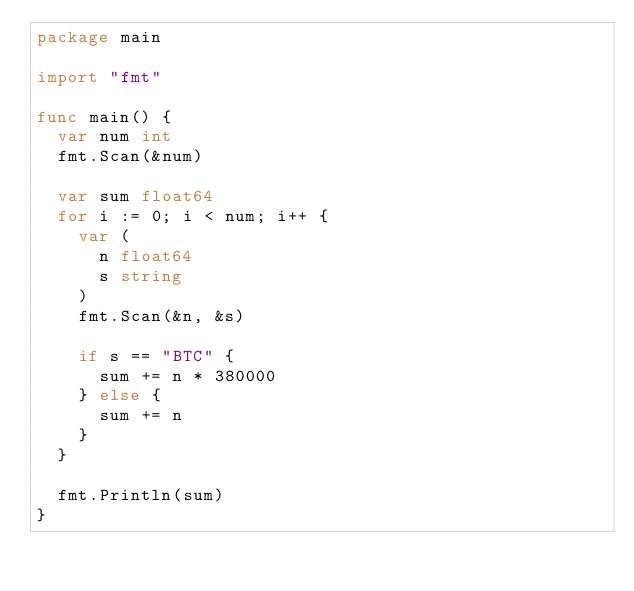<code> <loc_0><loc_0><loc_500><loc_500><_Go_>package main

import "fmt"

func main() {
	var num int
	fmt.Scan(&num)

	var sum float64
	for i := 0; i < num; i++ {
		var (
			n float64
			s string
		)
		fmt.Scan(&n, &s)

		if s == "BTC" {
			sum += n * 380000
		} else {
			sum += n
		}
	}

	fmt.Println(sum)
}
</code> 